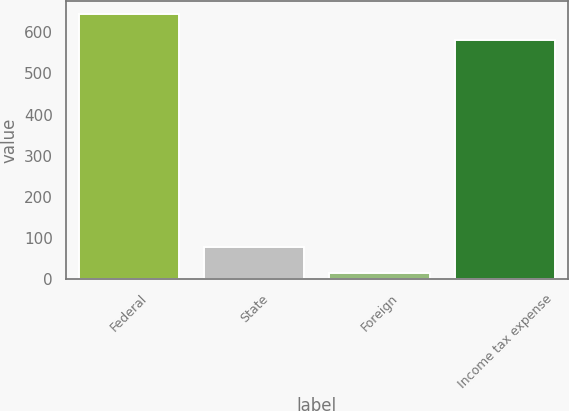Convert chart to OTSL. <chart><loc_0><loc_0><loc_500><loc_500><bar_chart><fcel>Federal<fcel>State<fcel>Foreign<fcel>Income tax expense<nl><fcel>643.6<fcel>78<fcel>14<fcel>581<nl></chart> 